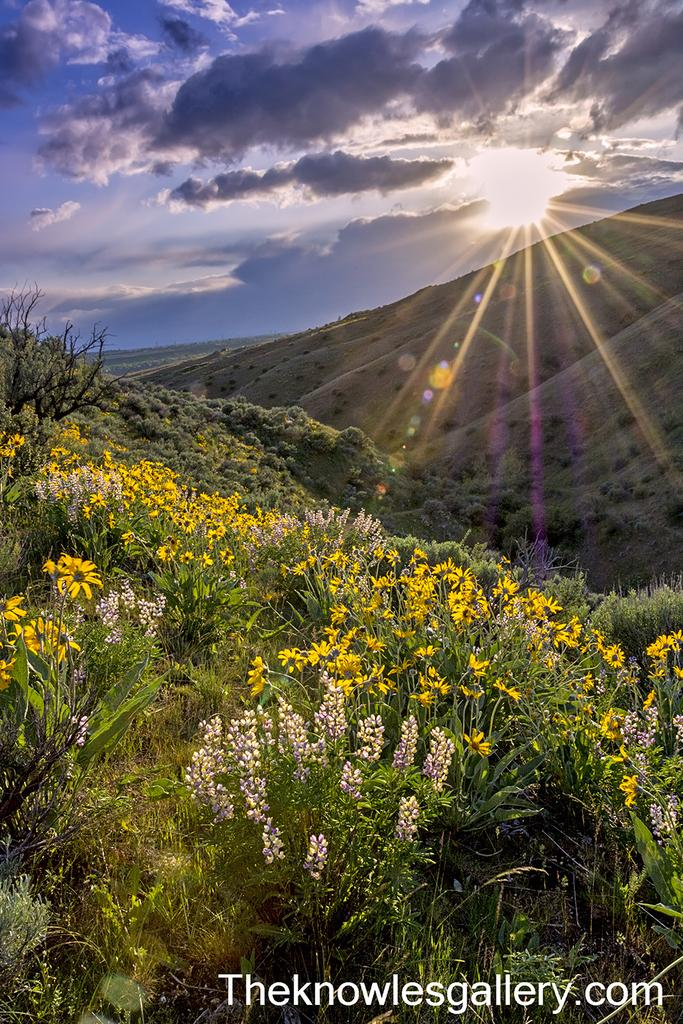What types of vegetation can be seen in the image? There are plants, flowers, and trees in the image. What type of landscape is depicted in the image? The image shows hills in the landscape. What can be seen in the background of the image? There are clouds and the sun visible in the background of the image. Is there any text present in the image? Yes, there is some text in the bottom right-hand corner of the image. What type of string is being used to support the knee of the person in the image? There is no person or knee present in the image; it features plants, flowers, trees, hills, clouds, the sun, and some text. Can you tell me how many pails are visible in the image? There are no pails present in the image. 